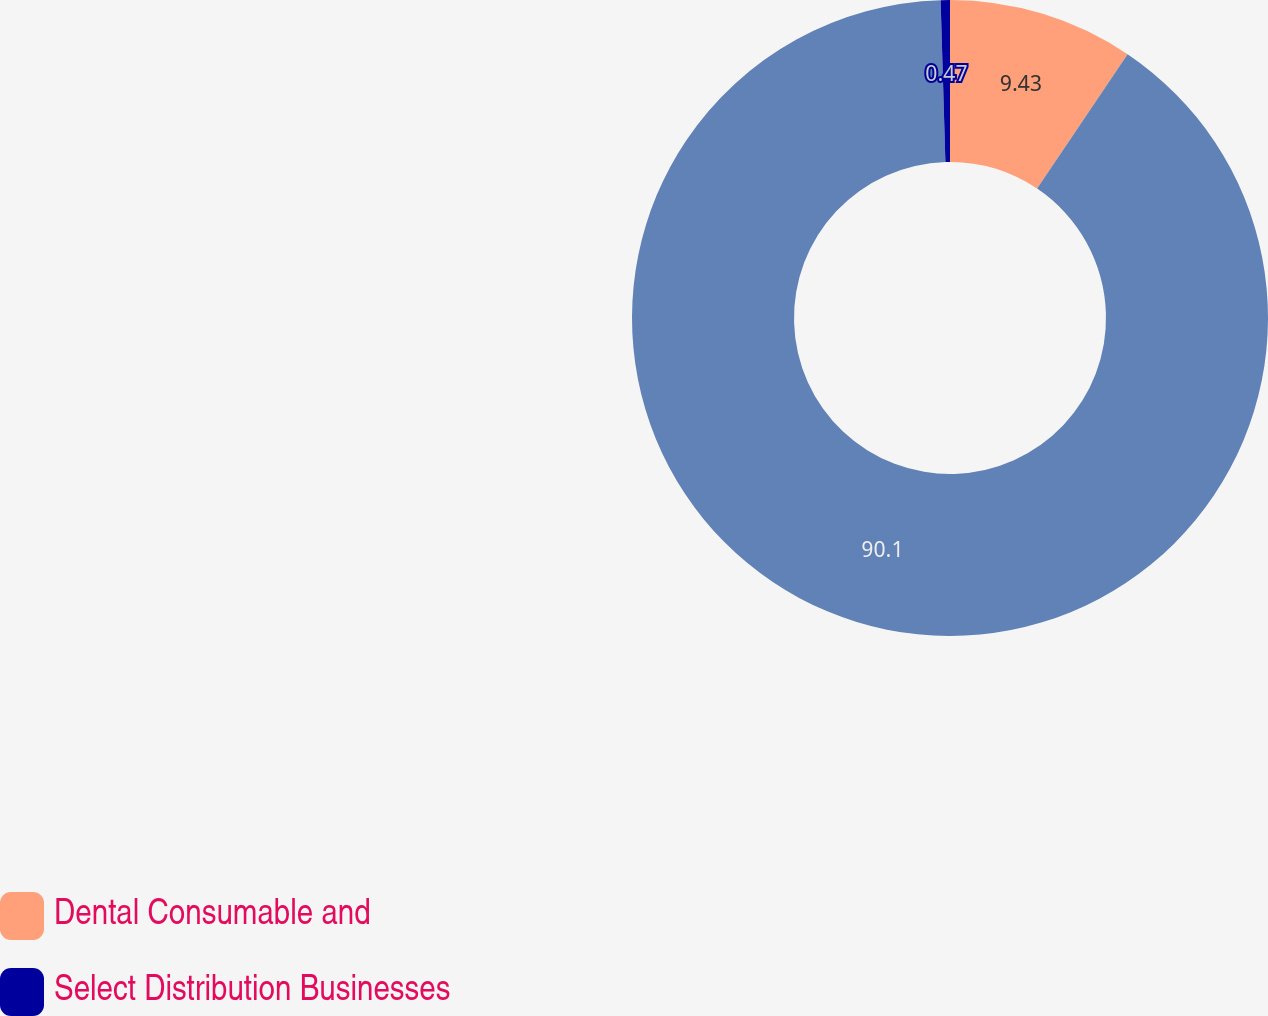Convert chart to OTSL. <chart><loc_0><loc_0><loc_500><loc_500><pie_chart><fcel>Dental Consumable and<fcel>Unnamed: 1<fcel>Select Distribution Businesses<nl><fcel>9.43%<fcel>90.1%<fcel>0.47%<nl></chart> 